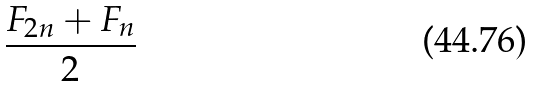Convert formula to latex. <formula><loc_0><loc_0><loc_500><loc_500>\frac { F _ { 2 n } + F _ { n } } { 2 }</formula> 